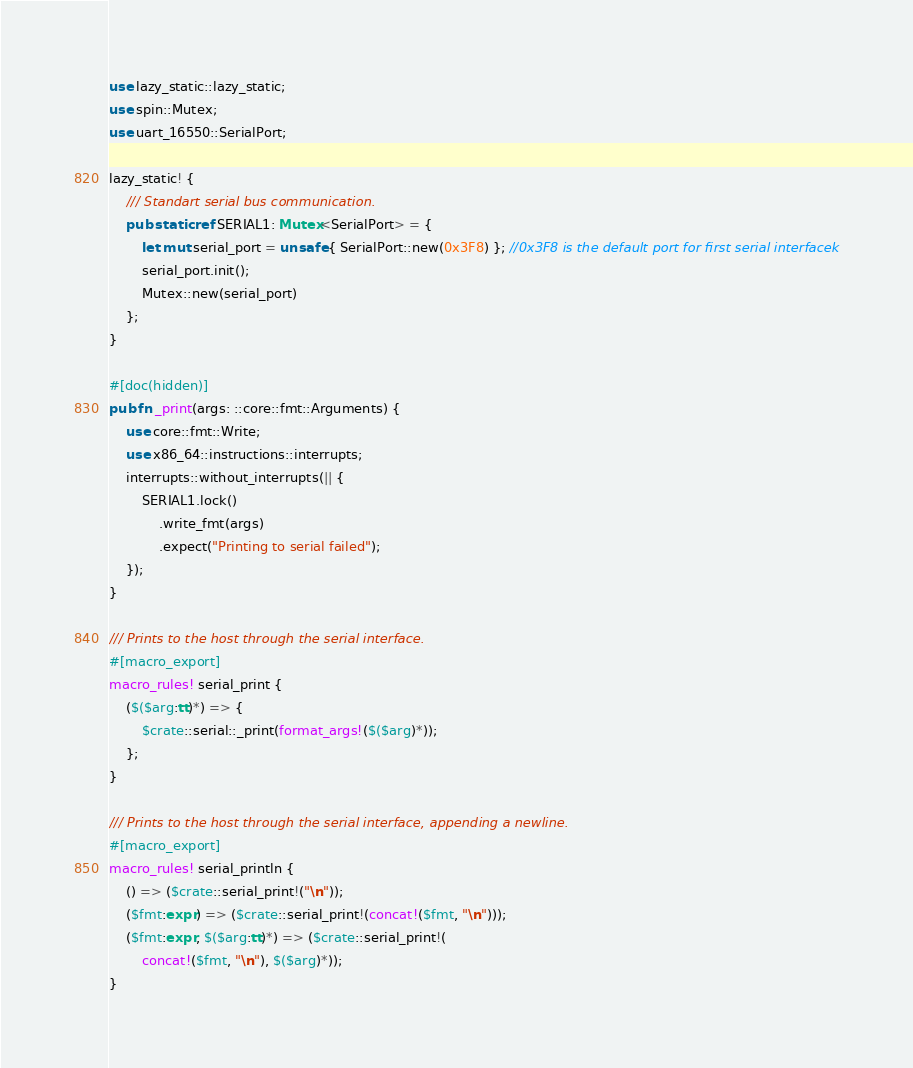Convert code to text. <code><loc_0><loc_0><loc_500><loc_500><_Rust_>use lazy_static::lazy_static;
use spin::Mutex;
use uart_16550::SerialPort;

lazy_static! {
    /// Standart serial bus communication.
    pub static ref SERIAL1: Mutex<SerialPort> = {
        let mut serial_port = unsafe { SerialPort::new(0x3F8) }; //0x3F8 is the default port for first serial interfacek
        serial_port.init();
        Mutex::new(serial_port)
    };
}

#[doc(hidden)]
pub fn _print(args: ::core::fmt::Arguments) {
    use core::fmt::Write;
    use x86_64::instructions::interrupts;
    interrupts::without_interrupts(|| {
        SERIAL1.lock()
            .write_fmt(args)
            .expect("Printing to serial failed");
    });
}

/// Prints to the host through the serial interface.
#[macro_export]
macro_rules! serial_print {
    ($($arg:tt)*) => {
        $crate::serial::_print(format_args!($($arg)*));
    };
}

/// Prints to the host through the serial interface, appending a newline.
#[macro_export]
macro_rules! serial_println {
    () => ($crate::serial_print!("\n"));
    ($fmt:expr) => ($crate::serial_print!(concat!($fmt, "\n")));
    ($fmt:expr, $($arg:tt)*) => ($crate::serial_print!(
        concat!($fmt, "\n"), $($arg)*));
}
</code> 